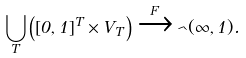<formula> <loc_0><loc_0><loc_500><loc_500>\bigcup _ { T } \left ( [ 0 , 1 ] ^ { T } \times V _ { T } \right ) \xrightarrow { F } \psi _ { \theta } ( \infty , 1 ) .</formula> 